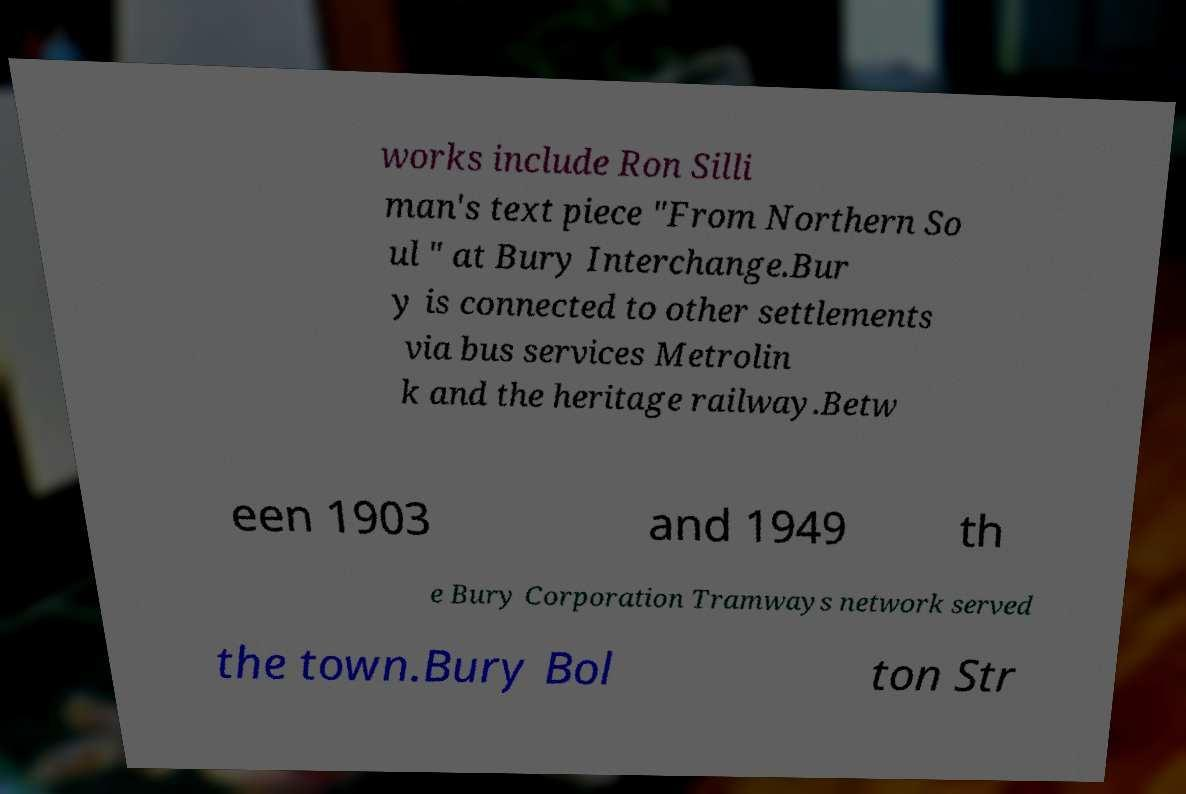Could you extract and type out the text from this image? works include Ron Silli man's text piece "From Northern So ul " at Bury Interchange.Bur y is connected to other settlements via bus services Metrolin k and the heritage railway.Betw een 1903 and 1949 th e Bury Corporation Tramways network served the town.Bury Bol ton Str 